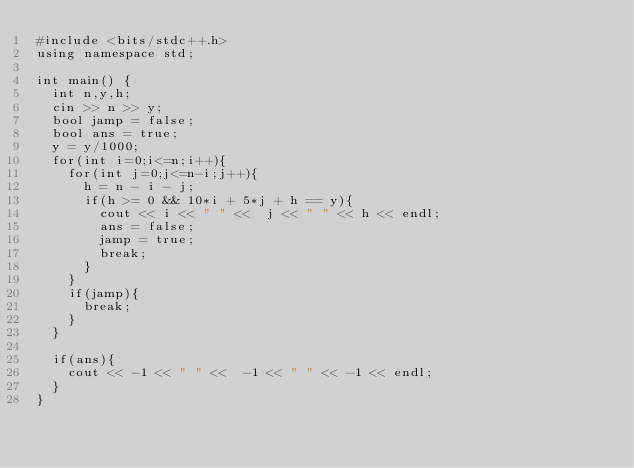Convert code to text. <code><loc_0><loc_0><loc_500><loc_500><_C++_>#include <bits/stdc++.h>
using namespace std;

int main() {
  int n,y,h;
  cin >> n >> y;
  bool jamp = false;
  bool ans = true;
  y = y/1000;
  for(int i=0;i<=n;i++){
    for(int j=0;j<=n-i;j++){
      h = n - i - j;
      if(h >= 0 && 10*i + 5*j + h == y){
        cout << i << " " <<  j << " " << h << endl;
        ans = false;
        jamp = true;
        break;
      }
    }
    if(jamp){
      break;
    }
  }
  
  if(ans){
    cout << -1 << " " <<  -1 << " " << -1 << endl;
  }
}

        
</code> 